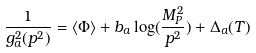<formula> <loc_0><loc_0><loc_500><loc_500>\frac { 1 } { g _ { a } ^ { 2 } ( p ^ { 2 } ) } = \langle \Phi \rangle + b _ { a } \log ( \frac { M _ { P } ^ { 2 } } { p ^ { 2 } } ) + \Delta _ { a } ( T )</formula> 